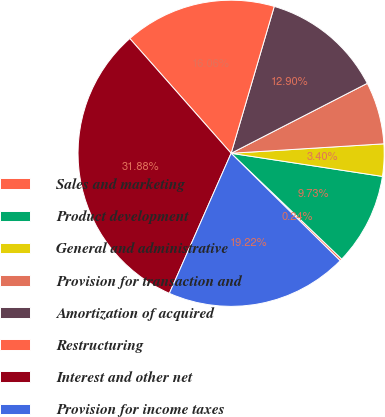<chart> <loc_0><loc_0><loc_500><loc_500><pie_chart><fcel>Sales and marketing<fcel>Product development<fcel>General and administrative<fcel>Provision for transaction and<fcel>Amortization of acquired<fcel>Restructuring<fcel>Interest and other net<fcel>Provision for income taxes<nl><fcel>0.24%<fcel>9.73%<fcel>3.4%<fcel>6.57%<fcel>12.9%<fcel>16.06%<fcel>31.88%<fcel>19.22%<nl></chart> 